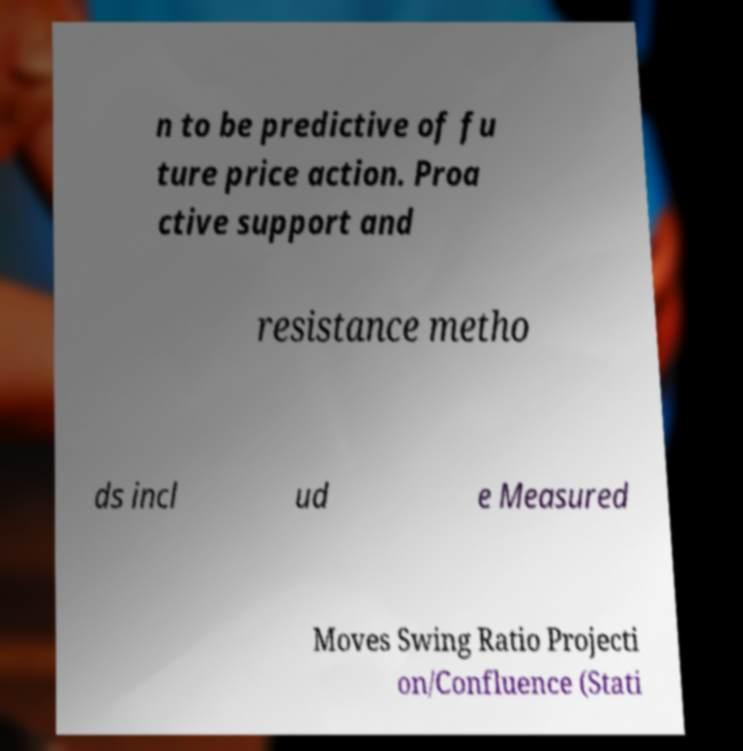Could you assist in decoding the text presented in this image and type it out clearly? n to be predictive of fu ture price action. Proa ctive support and resistance metho ds incl ud e Measured Moves Swing Ratio Projecti on/Confluence (Stati 